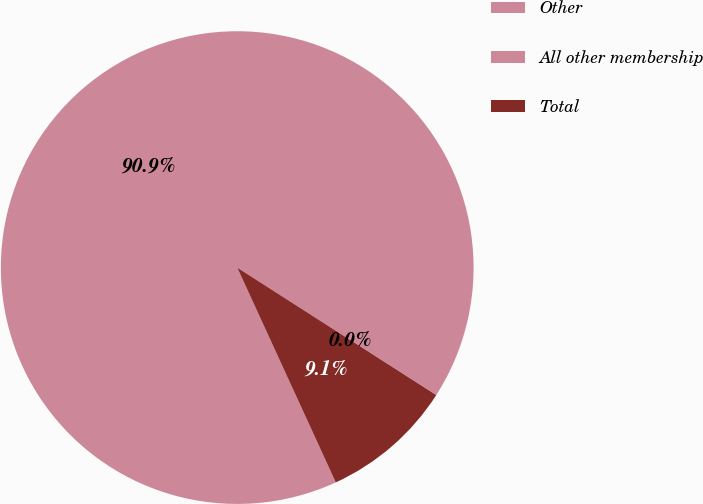<chart> <loc_0><loc_0><loc_500><loc_500><pie_chart><fcel>Other<fcel>All other membership<fcel>Total<nl><fcel>90.9%<fcel>0.01%<fcel>9.09%<nl></chart> 